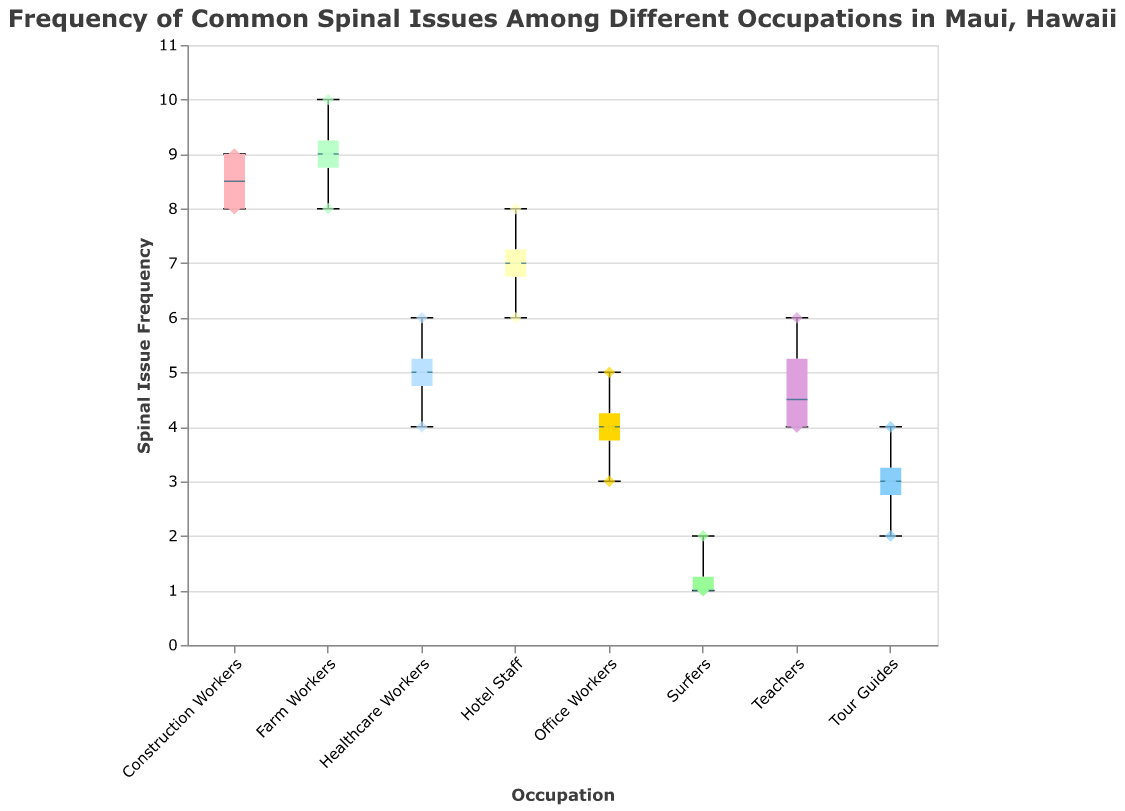How many occupations are included in the study? Count the different categories on the x-axis, each representing a unique occupation.
Answer: 8 Which occupation has the lowest median frequency of spinal issues? Identify the middle line (median) inside each boxplot and compare the heights across the occupations.
Answer: Surfers Which occupation has the highest median frequency of spinal issues? Identify the middle line (median) inside each boxplot and compare the heights across the occupations.
Answer: Farm Workers What is the range of spinal issue frequencies for Construction Workers? Observe the range from the minimum to the maximum "whiskers" in the boxplot for Construction Workers.
Answer: 8 to 9 Which two occupations have the widest range of spinal issue frequencies? Compare the distances from the minimum to the maximum whiskers in each boxplot.
Answer: Hotel Staff and Farm Workers For Teachers, what is the difference between the highest and lowest recorded spinal issue frequency? Locate the highest and lowest points (outliers) or edges of the whiskers for Teachers and calculate the difference.
Answer: 2 (6 - 4) How does the variability of spinal issue frequency for Tour Guides compare to Office Workers? Compare the lengths of the boxes and whiskers for Tour Guides and Office Workers. Notice which plot has a more spread out range of frequencies.
Answer: Tour Guides have a slightly smaller range than Office Workers Which occupation has the most consistent (least variable) spinal issue frequency? Identify the boxplot with the shortest box and whiskers, indicating less variability.
Answer: Surfers Among Farm Workers, Healthcare Workers, and Office Workers, who reported lower median spinal issue frequencies? Compare the medians (middle lines inside boxes) for the three specified occupations.
Answer: Healthcare Workers and Office Workers What is the relationship between the spinal issue frequency of Healthcare Workers and Teachers? Compare the positions of the middle lines (medians) and the ranges (boxes and whiskers) in their respective boxplots.
Answer: Similar medians and variability 